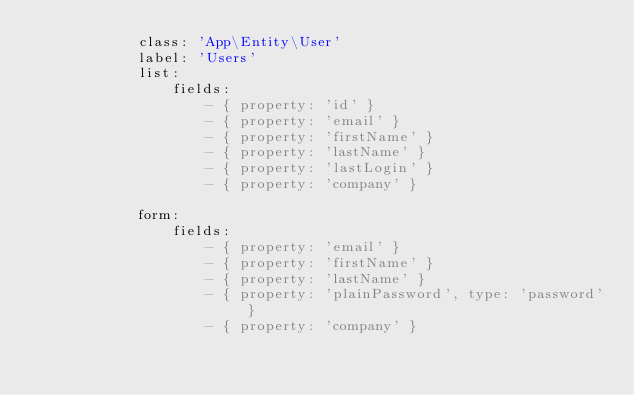Convert code to text. <code><loc_0><loc_0><loc_500><loc_500><_YAML_>            class: 'App\Entity\User'
            label: 'Users'
            list:
                fields:
                    - { property: 'id' }
                    - { property: 'email' }
                    - { property: 'firstName' }
                    - { property: 'lastName' }
                    - { property: 'lastLogin' }
                    - { property: 'company' }

            form:
                fields:
                    - { property: 'email' }
                    - { property: 'firstName' }
                    - { property: 'lastName' }
                    - { property: 'plainPassword', type: 'password' }
                    - { property: 'company' }
</code> 